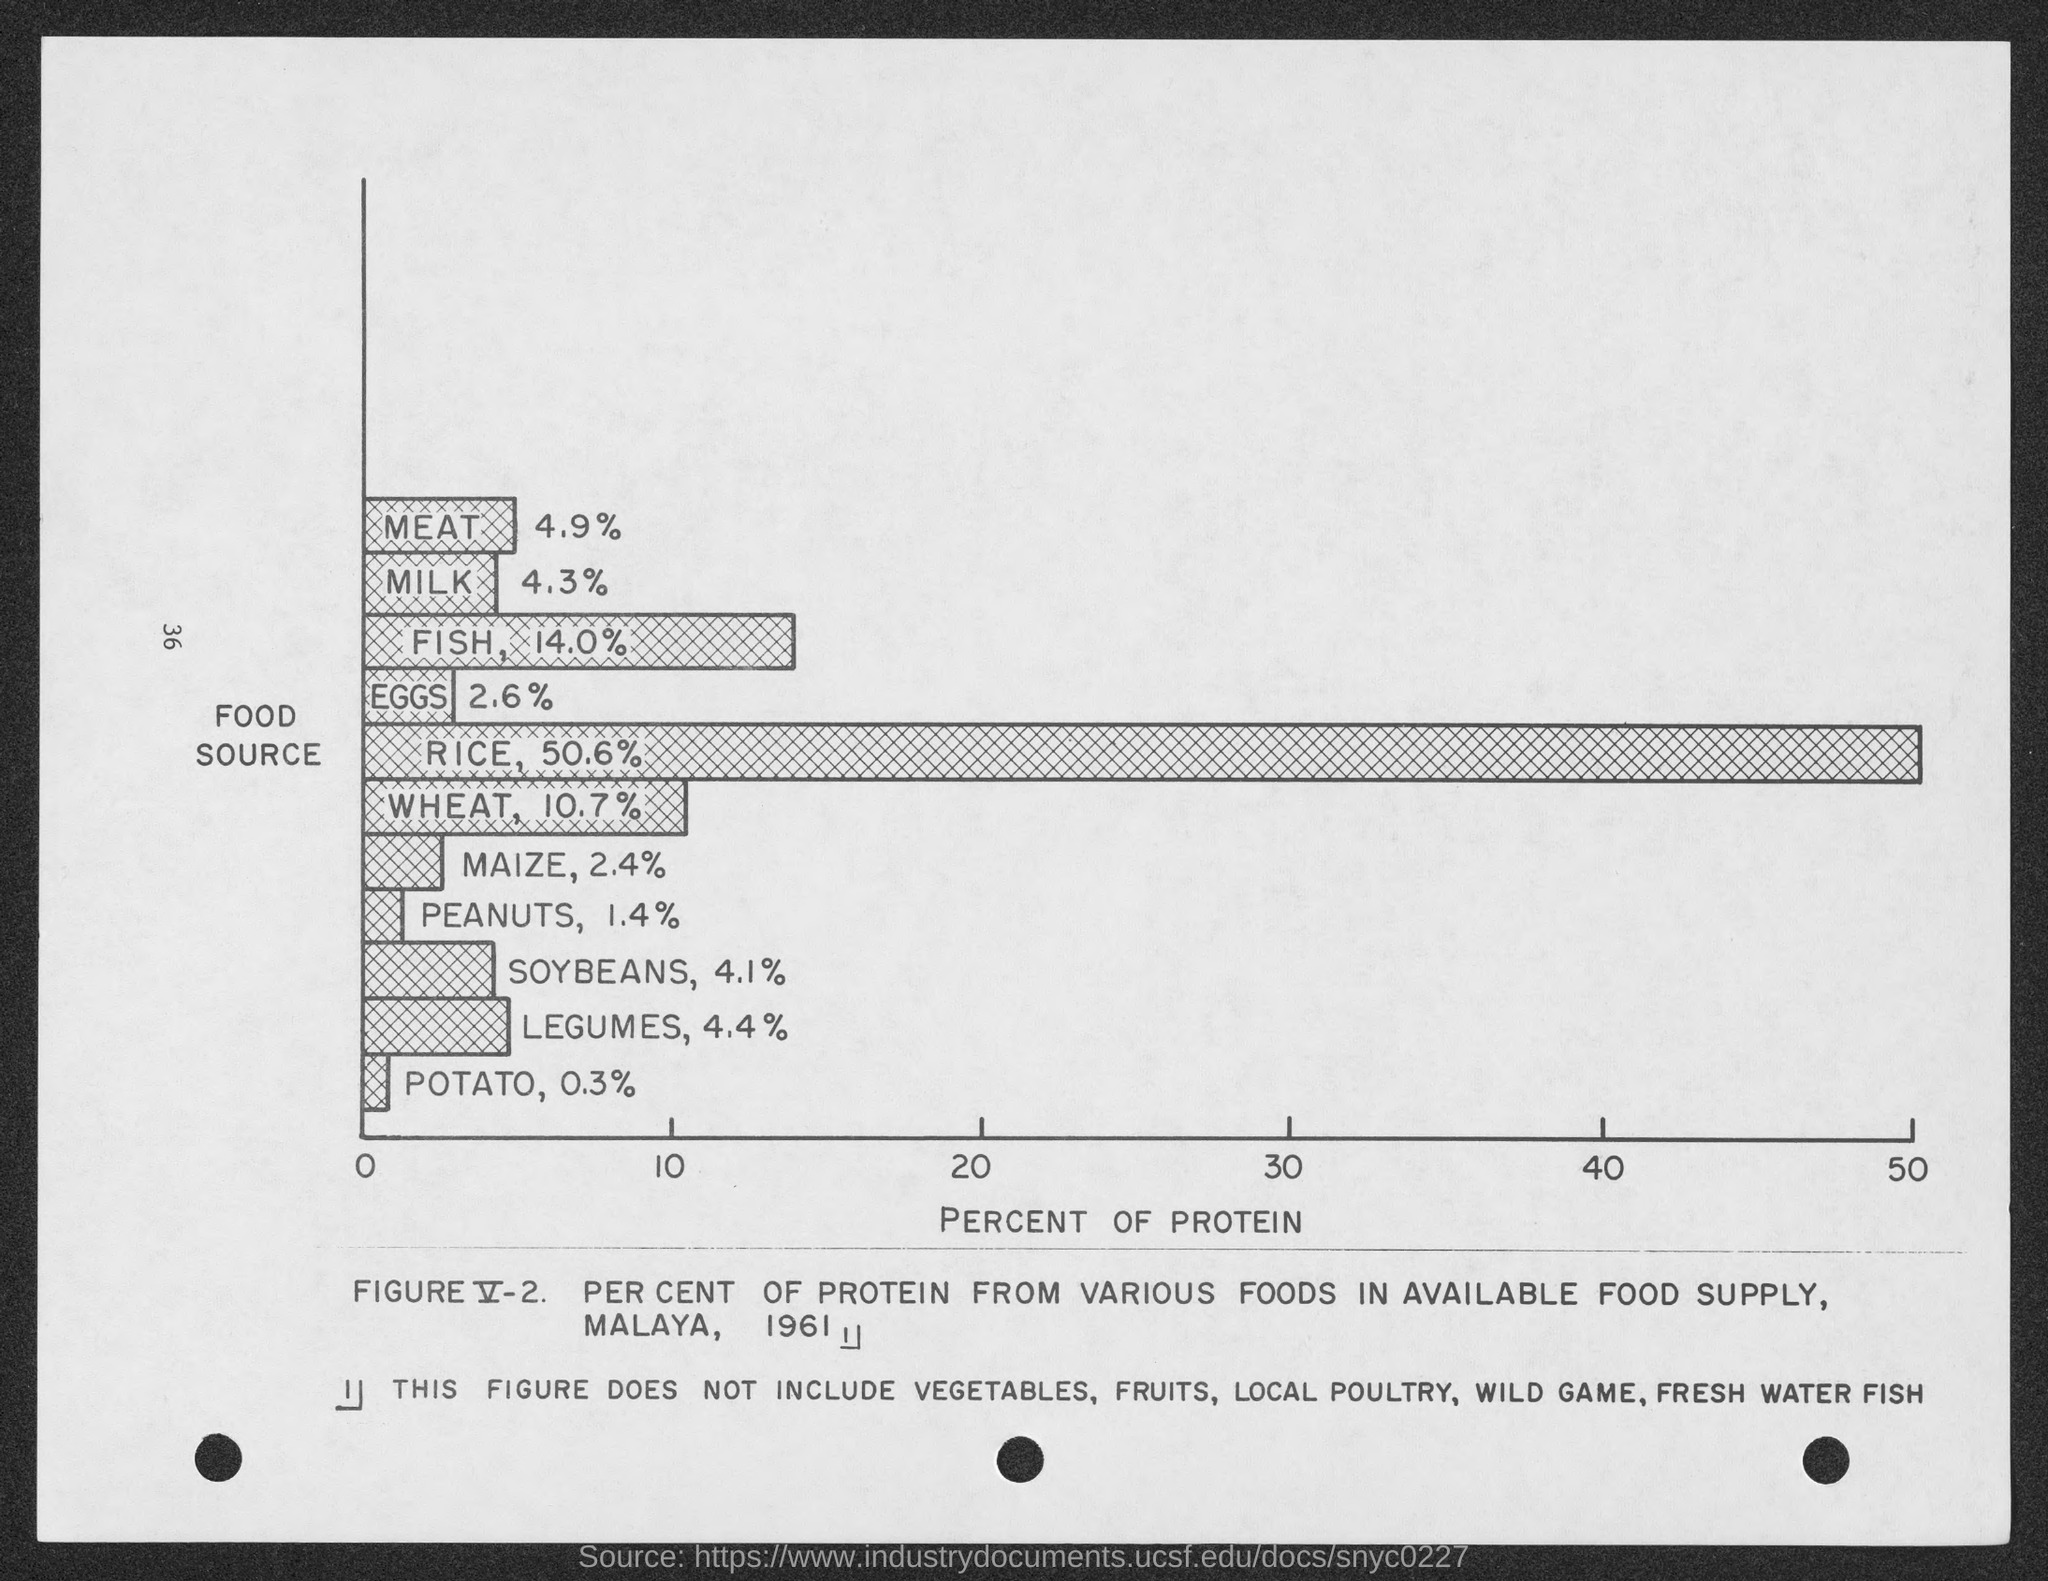Outline some significant characteristics in this image. According to my data, the percentage of protein in meat is 4.9%. The protein content of maize is approximately 2.4%, as determined by a recent analysis. Potatoes have the least amount of protein compared to other food items. The x-axis displays the percent of protein in the test samples. Rice has the highest percentage of protein compared to other food items. 